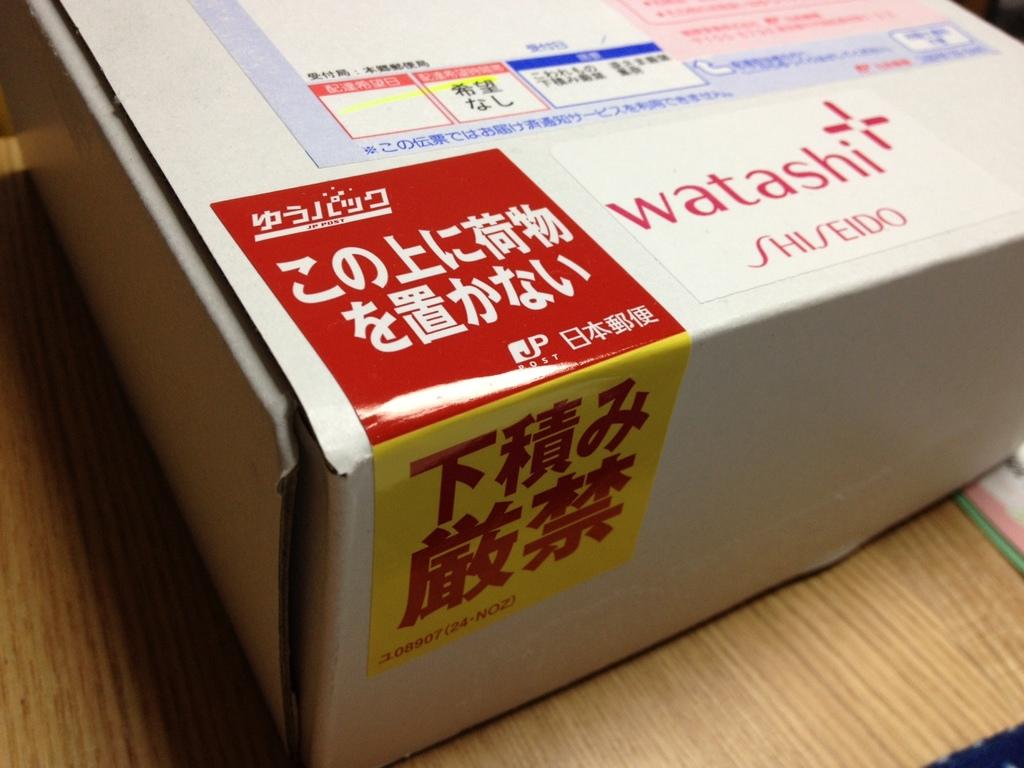What is the brand of this?
Keep it short and to the point. Watashi. What is in the box?
Make the answer very short. Unanswerable. 